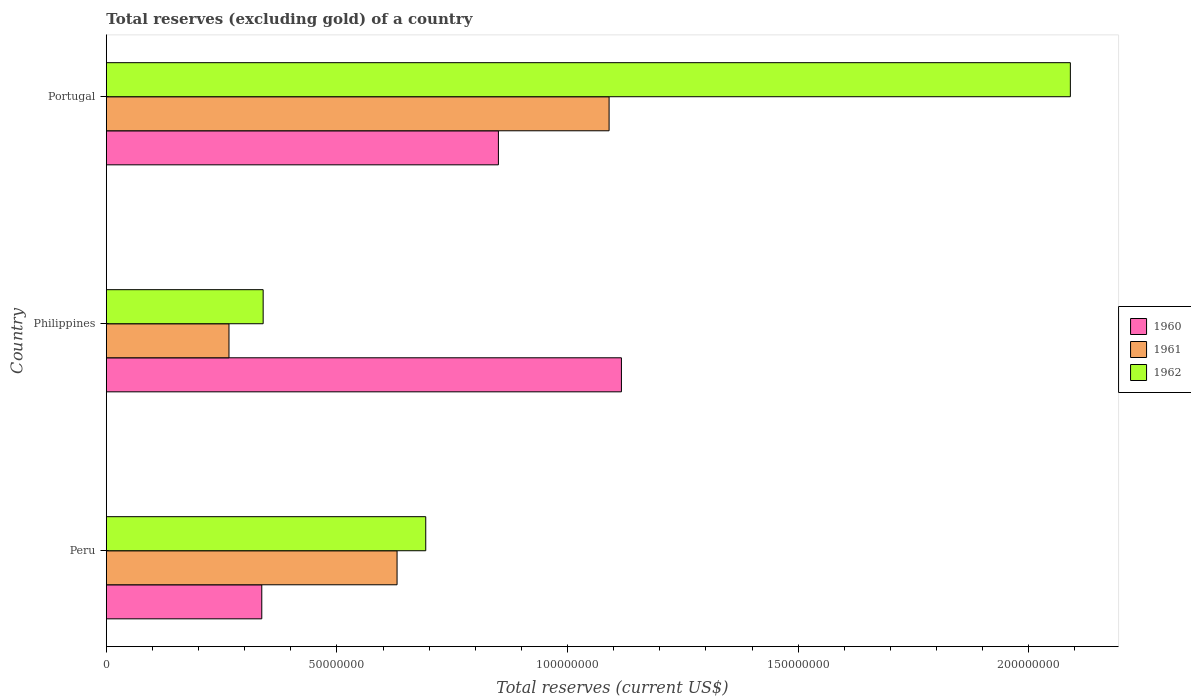How many different coloured bars are there?
Ensure brevity in your answer.  3. How many groups of bars are there?
Your response must be concise. 3. Are the number of bars on each tick of the Y-axis equal?
Keep it short and to the point. Yes. How many bars are there on the 1st tick from the top?
Provide a short and direct response. 3. What is the total reserves (excluding gold) in 1960 in Portugal?
Your answer should be very brief. 8.50e+07. Across all countries, what is the maximum total reserves (excluding gold) in 1962?
Offer a very short reply. 2.09e+08. Across all countries, what is the minimum total reserves (excluding gold) in 1960?
Give a very brief answer. 3.37e+07. What is the total total reserves (excluding gold) in 1961 in the graph?
Offer a terse response. 1.99e+08. What is the difference between the total reserves (excluding gold) in 1962 in Peru and that in Portugal?
Your answer should be compact. -1.40e+08. What is the difference between the total reserves (excluding gold) in 1960 in Peru and the total reserves (excluding gold) in 1961 in Portugal?
Provide a short and direct response. -7.53e+07. What is the average total reserves (excluding gold) in 1961 per country?
Your response must be concise. 6.62e+07. What is the difference between the total reserves (excluding gold) in 1962 and total reserves (excluding gold) in 1960 in Philippines?
Make the answer very short. -7.77e+07. In how many countries, is the total reserves (excluding gold) in 1960 greater than 190000000 US$?
Offer a terse response. 0. What is the ratio of the total reserves (excluding gold) in 1961 in Peru to that in Portugal?
Ensure brevity in your answer.  0.58. Is the total reserves (excluding gold) in 1961 in Peru less than that in Philippines?
Ensure brevity in your answer.  No. Is the difference between the total reserves (excluding gold) in 1962 in Peru and Portugal greater than the difference between the total reserves (excluding gold) in 1960 in Peru and Portugal?
Provide a short and direct response. No. What is the difference between the highest and the second highest total reserves (excluding gold) in 1962?
Provide a short and direct response. 1.40e+08. What is the difference between the highest and the lowest total reserves (excluding gold) in 1962?
Your response must be concise. 1.75e+08. In how many countries, is the total reserves (excluding gold) in 1960 greater than the average total reserves (excluding gold) in 1960 taken over all countries?
Your answer should be compact. 2. Is the sum of the total reserves (excluding gold) in 1960 in Peru and Portugal greater than the maximum total reserves (excluding gold) in 1961 across all countries?
Your response must be concise. Yes. What does the 1st bar from the top in Peru represents?
Your answer should be compact. 1962. What does the 1st bar from the bottom in Philippines represents?
Provide a succinct answer. 1960. Is it the case that in every country, the sum of the total reserves (excluding gold) in 1962 and total reserves (excluding gold) in 1961 is greater than the total reserves (excluding gold) in 1960?
Offer a terse response. No. What is the difference between two consecutive major ticks on the X-axis?
Give a very brief answer. 5.00e+07. Does the graph contain any zero values?
Your answer should be very brief. No. Does the graph contain grids?
Your answer should be compact. No. How many legend labels are there?
Provide a succinct answer. 3. How are the legend labels stacked?
Offer a very short reply. Vertical. What is the title of the graph?
Make the answer very short. Total reserves (excluding gold) of a country. What is the label or title of the X-axis?
Provide a short and direct response. Total reserves (current US$). What is the label or title of the Y-axis?
Your answer should be very brief. Country. What is the Total reserves (current US$) in 1960 in Peru?
Ensure brevity in your answer.  3.37e+07. What is the Total reserves (current US$) of 1961 in Peru?
Ensure brevity in your answer.  6.30e+07. What is the Total reserves (current US$) in 1962 in Peru?
Offer a terse response. 6.92e+07. What is the Total reserves (current US$) in 1960 in Philippines?
Offer a terse response. 1.12e+08. What is the Total reserves (current US$) of 1961 in Philippines?
Your answer should be compact. 2.66e+07. What is the Total reserves (current US$) of 1962 in Philippines?
Ensure brevity in your answer.  3.40e+07. What is the Total reserves (current US$) of 1960 in Portugal?
Provide a succinct answer. 8.50e+07. What is the Total reserves (current US$) of 1961 in Portugal?
Provide a short and direct response. 1.09e+08. What is the Total reserves (current US$) of 1962 in Portugal?
Ensure brevity in your answer.  2.09e+08. Across all countries, what is the maximum Total reserves (current US$) of 1960?
Give a very brief answer. 1.12e+08. Across all countries, what is the maximum Total reserves (current US$) of 1961?
Your response must be concise. 1.09e+08. Across all countries, what is the maximum Total reserves (current US$) of 1962?
Your answer should be very brief. 2.09e+08. Across all countries, what is the minimum Total reserves (current US$) of 1960?
Your answer should be compact. 3.37e+07. Across all countries, what is the minimum Total reserves (current US$) in 1961?
Give a very brief answer. 2.66e+07. Across all countries, what is the minimum Total reserves (current US$) of 1962?
Your answer should be compact. 3.40e+07. What is the total Total reserves (current US$) of 1960 in the graph?
Your answer should be very brief. 2.30e+08. What is the total Total reserves (current US$) of 1961 in the graph?
Offer a terse response. 1.99e+08. What is the total Total reserves (current US$) of 1962 in the graph?
Provide a succinct answer. 3.12e+08. What is the difference between the Total reserves (current US$) of 1960 in Peru and that in Philippines?
Offer a terse response. -7.80e+07. What is the difference between the Total reserves (current US$) of 1961 in Peru and that in Philippines?
Offer a terse response. 3.64e+07. What is the difference between the Total reserves (current US$) in 1962 in Peru and that in Philippines?
Provide a short and direct response. 3.52e+07. What is the difference between the Total reserves (current US$) of 1960 in Peru and that in Portugal?
Offer a very short reply. -5.13e+07. What is the difference between the Total reserves (current US$) in 1961 in Peru and that in Portugal?
Keep it short and to the point. -4.60e+07. What is the difference between the Total reserves (current US$) of 1962 in Peru and that in Portugal?
Provide a succinct answer. -1.40e+08. What is the difference between the Total reserves (current US$) in 1960 in Philippines and that in Portugal?
Provide a short and direct response. 2.67e+07. What is the difference between the Total reserves (current US$) in 1961 in Philippines and that in Portugal?
Provide a succinct answer. -8.24e+07. What is the difference between the Total reserves (current US$) in 1962 in Philippines and that in Portugal?
Provide a succinct answer. -1.75e+08. What is the difference between the Total reserves (current US$) in 1960 in Peru and the Total reserves (current US$) in 1961 in Philippines?
Your answer should be compact. 7.11e+06. What is the difference between the Total reserves (current US$) of 1960 in Peru and the Total reserves (current US$) of 1962 in Philippines?
Offer a terse response. -3.00e+05. What is the difference between the Total reserves (current US$) of 1961 in Peru and the Total reserves (current US$) of 1962 in Philippines?
Offer a very short reply. 2.90e+07. What is the difference between the Total reserves (current US$) of 1960 in Peru and the Total reserves (current US$) of 1961 in Portugal?
Offer a very short reply. -7.53e+07. What is the difference between the Total reserves (current US$) of 1960 in Peru and the Total reserves (current US$) of 1962 in Portugal?
Offer a terse response. -1.75e+08. What is the difference between the Total reserves (current US$) in 1961 in Peru and the Total reserves (current US$) in 1962 in Portugal?
Your response must be concise. -1.46e+08. What is the difference between the Total reserves (current US$) of 1960 in Philippines and the Total reserves (current US$) of 1961 in Portugal?
Your answer should be very brief. 2.67e+06. What is the difference between the Total reserves (current US$) in 1960 in Philippines and the Total reserves (current US$) in 1962 in Portugal?
Your answer should be very brief. -9.73e+07. What is the difference between the Total reserves (current US$) of 1961 in Philippines and the Total reserves (current US$) of 1962 in Portugal?
Provide a short and direct response. -1.82e+08. What is the average Total reserves (current US$) of 1960 per country?
Your answer should be very brief. 7.68e+07. What is the average Total reserves (current US$) of 1961 per country?
Your response must be concise. 6.62e+07. What is the average Total reserves (current US$) in 1962 per country?
Your answer should be compact. 1.04e+08. What is the difference between the Total reserves (current US$) of 1960 and Total reserves (current US$) of 1961 in Peru?
Give a very brief answer. -2.93e+07. What is the difference between the Total reserves (current US$) of 1960 and Total reserves (current US$) of 1962 in Peru?
Make the answer very short. -3.55e+07. What is the difference between the Total reserves (current US$) of 1961 and Total reserves (current US$) of 1962 in Peru?
Provide a short and direct response. -6.22e+06. What is the difference between the Total reserves (current US$) in 1960 and Total reserves (current US$) in 1961 in Philippines?
Make the answer very short. 8.51e+07. What is the difference between the Total reserves (current US$) in 1960 and Total reserves (current US$) in 1962 in Philippines?
Offer a terse response. 7.77e+07. What is the difference between the Total reserves (current US$) of 1961 and Total reserves (current US$) of 1962 in Philippines?
Offer a very short reply. -7.41e+06. What is the difference between the Total reserves (current US$) of 1960 and Total reserves (current US$) of 1961 in Portugal?
Your answer should be very brief. -2.40e+07. What is the difference between the Total reserves (current US$) in 1960 and Total reserves (current US$) in 1962 in Portugal?
Provide a short and direct response. -1.24e+08. What is the difference between the Total reserves (current US$) in 1961 and Total reserves (current US$) in 1962 in Portugal?
Make the answer very short. -1.00e+08. What is the ratio of the Total reserves (current US$) of 1960 in Peru to that in Philippines?
Ensure brevity in your answer.  0.3. What is the ratio of the Total reserves (current US$) of 1961 in Peru to that in Philippines?
Your answer should be compact. 2.37. What is the ratio of the Total reserves (current US$) in 1962 in Peru to that in Philippines?
Offer a terse response. 2.04. What is the ratio of the Total reserves (current US$) in 1960 in Peru to that in Portugal?
Give a very brief answer. 0.4. What is the ratio of the Total reserves (current US$) of 1961 in Peru to that in Portugal?
Provide a short and direct response. 0.58. What is the ratio of the Total reserves (current US$) in 1962 in Peru to that in Portugal?
Your response must be concise. 0.33. What is the ratio of the Total reserves (current US$) in 1960 in Philippines to that in Portugal?
Your answer should be compact. 1.31. What is the ratio of the Total reserves (current US$) of 1961 in Philippines to that in Portugal?
Make the answer very short. 0.24. What is the ratio of the Total reserves (current US$) of 1962 in Philippines to that in Portugal?
Offer a very short reply. 0.16. What is the difference between the highest and the second highest Total reserves (current US$) in 1960?
Provide a succinct answer. 2.67e+07. What is the difference between the highest and the second highest Total reserves (current US$) in 1961?
Your response must be concise. 4.60e+07. What is the difference between the highest and the second highest Total reserves (current US$) in 1962?
Make the answer very short. 1.40e+08. What is the difference between the highest and the lowest Total reserves (current US$) of 1960?
Provide a succinct answer. 7.80e+07. What is the difference between the highest and the lowest Total reserves (current US$) in 1961?
Your answer should be very brief. 8.24e+07. What is the difference between the highest and the lowest Total reserves (current US$) of 1962?
Your response must be concise. 1.75e+08. 